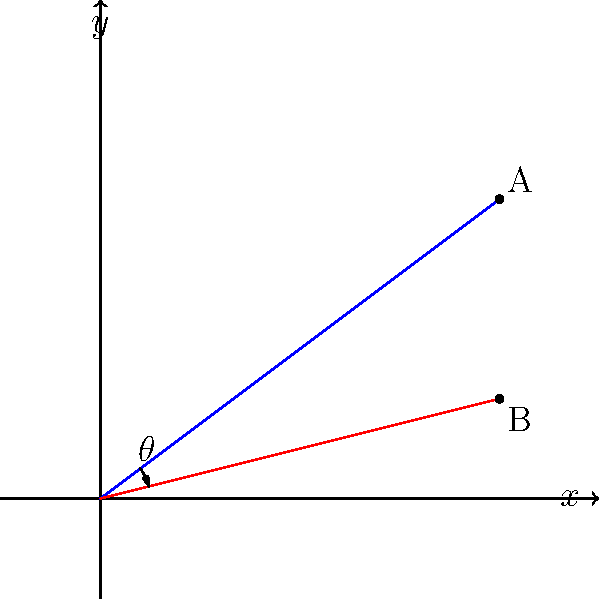On a guitar fretboard, two strings intersect at the origin (0,0) of a coordinate system. The blue string extends to point A(4,3), while the red string extends to point B(4,1). What is the measure of the angle $\theta$ between these two strings? Let's approach this step-by-step:

1) We can treat the strings as vectors from the origin to points A and B.

2) The angle between two vectors can be found using the arctangent of the slope difference:

   $\theta = \arctan(\frac{m_1 - m_2}{1 + m_1m_2})$

   Where $m_1$ and $m_2$ are the slopes of the two lines.

3) For the blue string (to point A):
   $m_1 = \frac{3}{4} = 0.75$

4) For the red string (to point B):
   $m_2 = \frac{1}{4} = 0.25$

5) Plugging into our formula:

   $\theta = \arctan(\frac{0.75 - 0.25}{1 + (0.75)(0.25)})$

6) Simplify:
   $\theta = \arctan(\frac{0.5}{1.1875}) = \arctan(0.42105)$

7) Calculate:
   $\theta \approx 22.8^\circ$

This angle represents the difference in pitch between the two strings, which contributes to the raw, dissonant sound often found in grunge music.
Answer: $22.8^\circ$ 